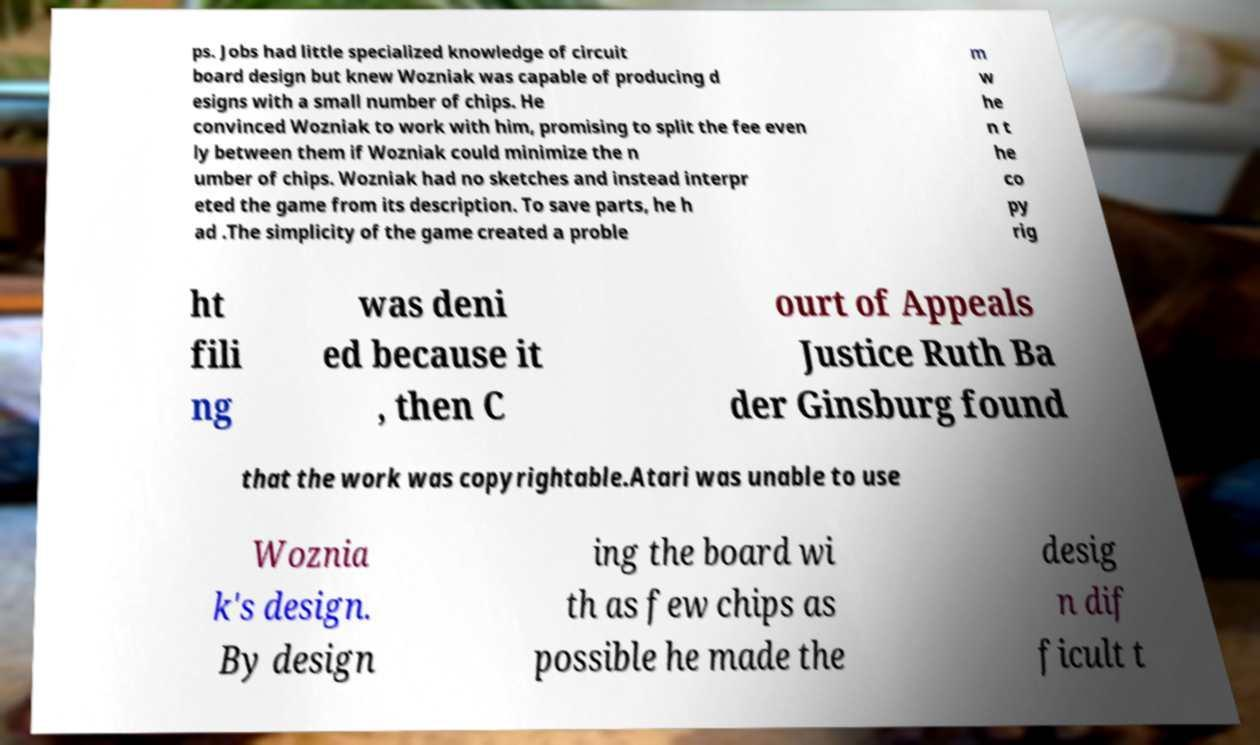I need the written content from this picture converted into text. Can you do that? ps. Jobs had little specialized knowledge of circuit board design but knew Wozniak was capable of producing d esigns with a small number of chips. He convinced Wozniak to work with him, promising to split the fee even ly between them if Wozniak could minimize the n umber of chips. Wozniak had no sketches and instead interpr eted the game from its description. To save parts, he h ad .The simplicity of the game created a proble m w he n t he co py rig ht fili ng was deni ed because it , then C ourt of Appeals Justice Ruth Ba der Ginsburg found that the work was copyrightable.Atari was unable to use Woznia k's design. By design ing the board wi th as few chips as possible he made the desig n dif ficult t 